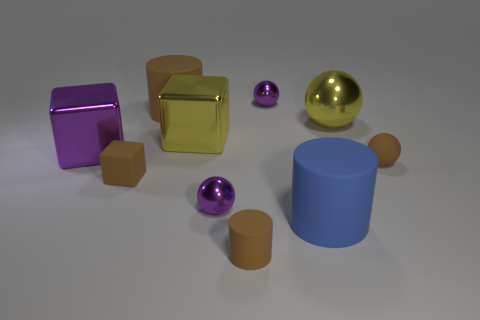Subtract all brown cylinders. How many cylinders are left? 1 Subtract all purple metal blocks. How many blocks are left? 2 Subtract all blocks. How many objects are left? 7 Subtract all yellow spheres. How many red cylinders are left? 0 Subtract all tiny brown rubber blocks. Subtract all blue objects. How many objects are left? 8 Add 2 small metal spheres. How many small metal spheres are left? 4 Add 9 small cyan rubber objects. How many small cyan rubber objects exist? 9 Subtract 0 blue blocks. How many objects are left? 10 Subtract 3 cubes. How many cubes are left? 0 Subtract all brown cylinders. Subtract all red blocks. How many cylinders are left? 1 